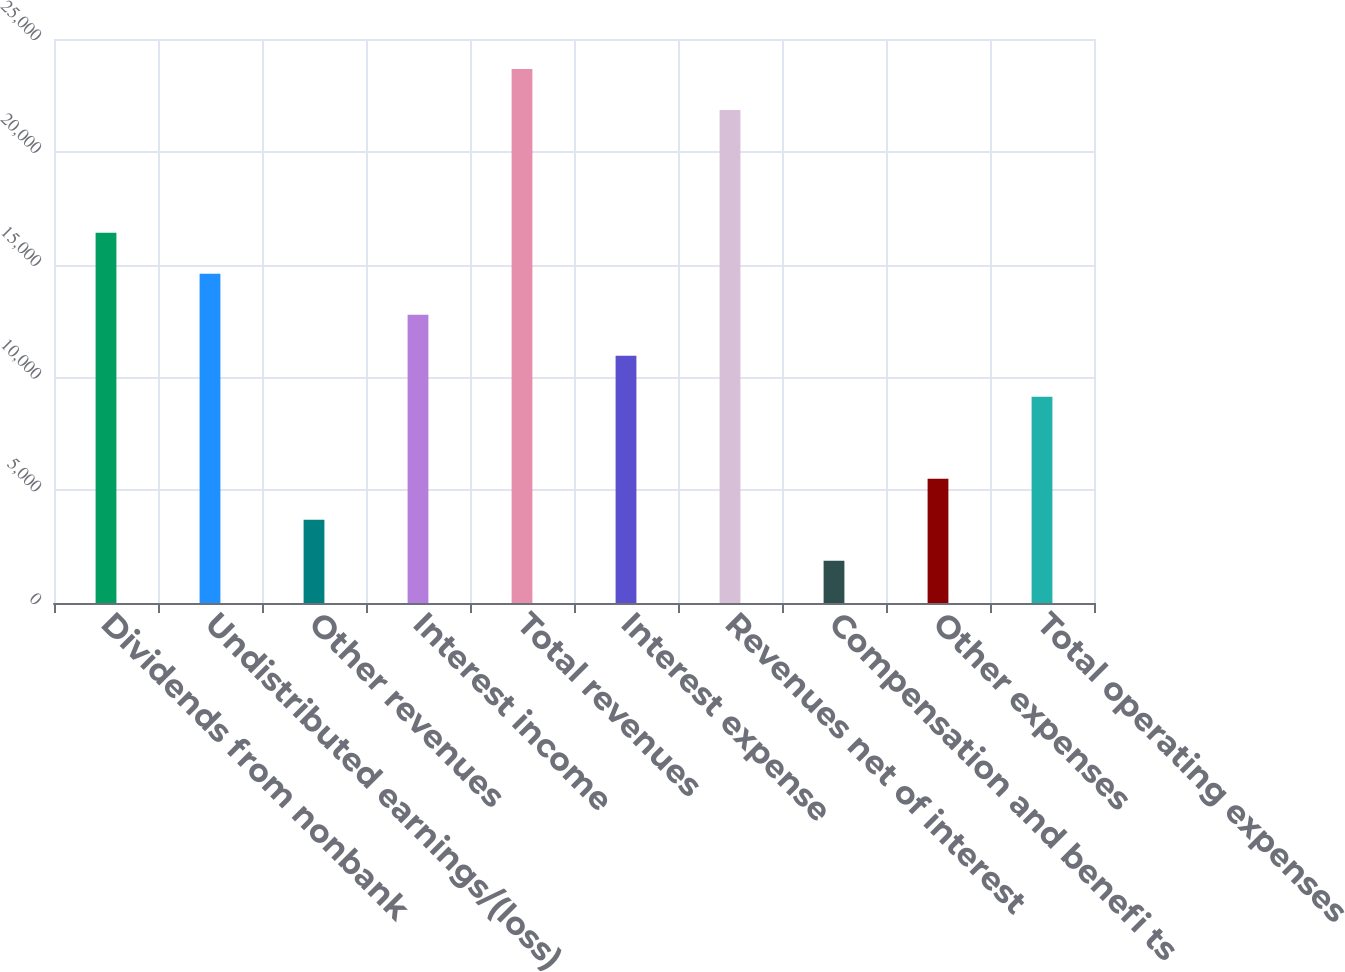Convert chart. <chart><loc_0><loc_0><loc_500><loc_500><bar_chart><fcel>Dividends from nonbank<fcel>Undistributed earnings/(loss)<fcel>Other revenues<fcel>Interest income<fcel>Total revenues<fcel>Interest expense<fcel>Revenues net of interest<fcel>Compensation and benefi ts<fcel>Other expenses<fcel>Total operating expenses<nl><fcel>16407.2<fcel>14590.4<fcel>3689.6<fcel>12773.6<fcel>23674.4<fcel>10956.8<fcel>21857.6<fcel>1872.8<fcel>5506.4<fcel>9140<nl></chart> 